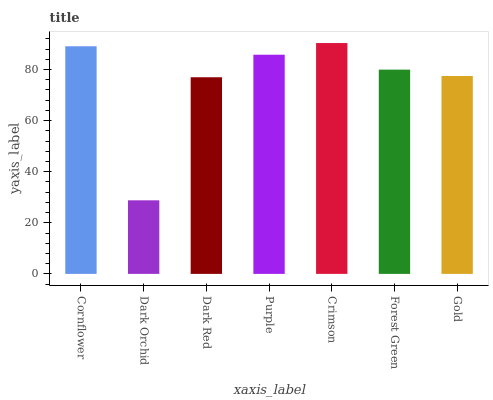Is Dark Orchid the minimum?
Answer yes or no. Yes. Is Crimson the maximum?
Answer yes or no. Yes. Is Dark Red the minimum?
Answer yes or no. No. Is Dark Red the maximum?
Answer yes or no. No. Is Dark Red greater than Dark Orchid?
Answer yes or no. Yes. Is Dark Orchid less than Dark Red?
Answer yes or no. Yes. Is Dark Orchid greater than Dark Red?
Answer yes or no. No. Is Dark Red less than Dark Orchid?
Answer yes or no. No. Is Forest Green the high median?
Answer yes or no. Yes. Is Forest Green the low median?
Answer yes or no. Yes. Is Purple the high median?
Answer yes or no. No. Is Gold the low median?
Answer yes or no. No. 